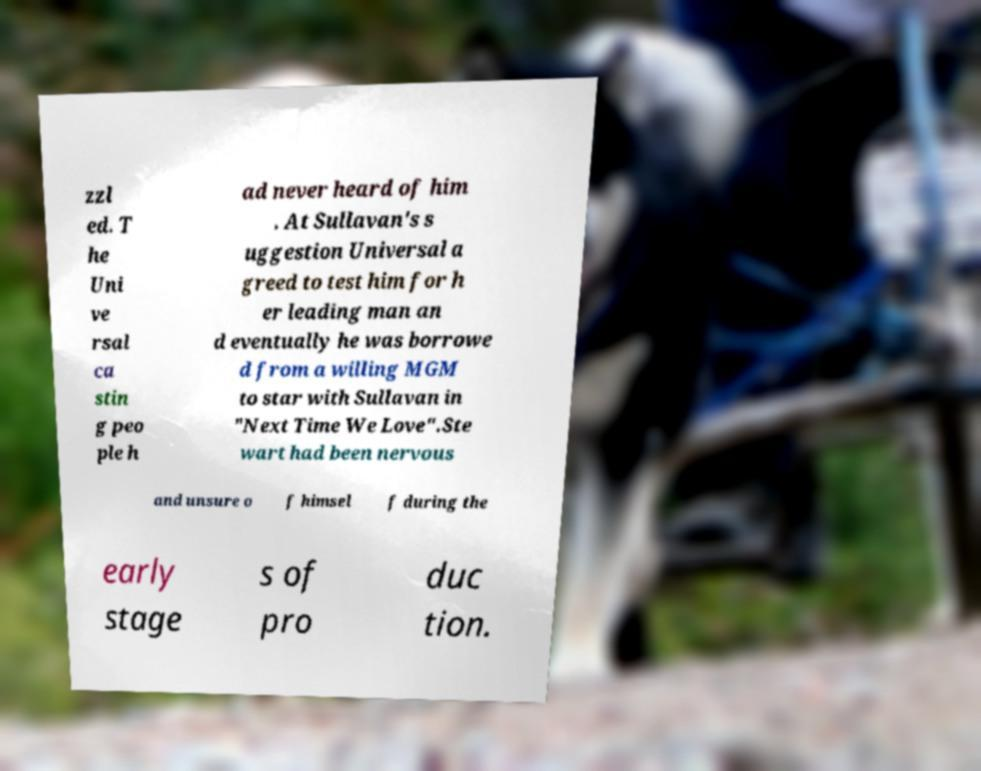What messages or text are displayed in this image? I need them in a readable, typed format. zzl ed. T he Uni ve rsal ca stin g peo ple h ad never heard of him . At Sullavan's s uggestion Universal a greed to test him for h er leading man an d eventually he was borrowe d from a willing MGM to star with Sullavan in "Next Time We Love".Ste wart had been nervous and unsure o f himsel f during the early stage s of pro duc tion. 